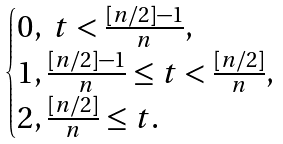Convert formula to latex. <formula><loc_0><loc_0><loc_500><loc_500>\begin{cases} 0 , \ t < \frac { [ n / 2 ] - 1 } n , \\ 1 , \frac { [ n / 2 ] - 1 } n \leq t < \frac { [ n / 2 ] } n , \\ 2 , \frac { [ n / 2 ] } n \leq t . \end{cases}</formula> 